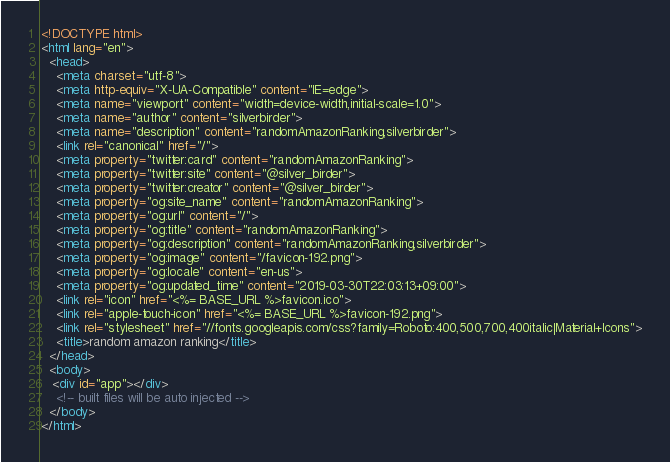<code> <loc_0><loc_0><loc_500><loc_500><_HTML_><!DOCTYPE html>
<html lang="en">
  <head>
    <meta charset="utf-8">
    <meta http-equiv="X-UA-Compatible" content="IE=edge">
    <meta name="viewport" content="width=device-width,initial-scale=1.0">
    <meta name="author" content="silverbirder">
    <meta name="description" content="randomAmazonRanking,silverbirder">
    <link rel="canonical" href="/">
    <meta property="twitter:card" content="randomAmazonRanking">
    <meta property="twitter:site" content="@silver_birder">
    <meta property="twitter:creator" content="@silver_birder">
    <meta property="og:site_name" content="randomAmazonRanking">
    <meta property="og:url" content="/">
    <meta property="og:title" content="randomAmazonRanking">
    <meta property="og:description" content="randomAmazonRanking,silverbirder">
    <meta property="og:image" content="/favicon-192.png">
    <meta property="og:locale" content="en-us">
    <meta property="og:updated_time" content="2019-03-30T22:03:13+09:00">
    <link rel="icon" href="<%= BASE_URL %>favicon.ico">
    <link rel="apple-touch-icon" href="<%= BASE_URL %>favicon-192.png">
    <link rel="stylesheet" href="//fonts.googleapis.com/css?family=Roboto:400,500,700,400italic|Material+Icons">
    <title>random amazon ranking</title>
  </head>
  <body>
   <div id="app"></div>
    <!-- built files will be auto injected -->
  </body>
</html>
</code> 